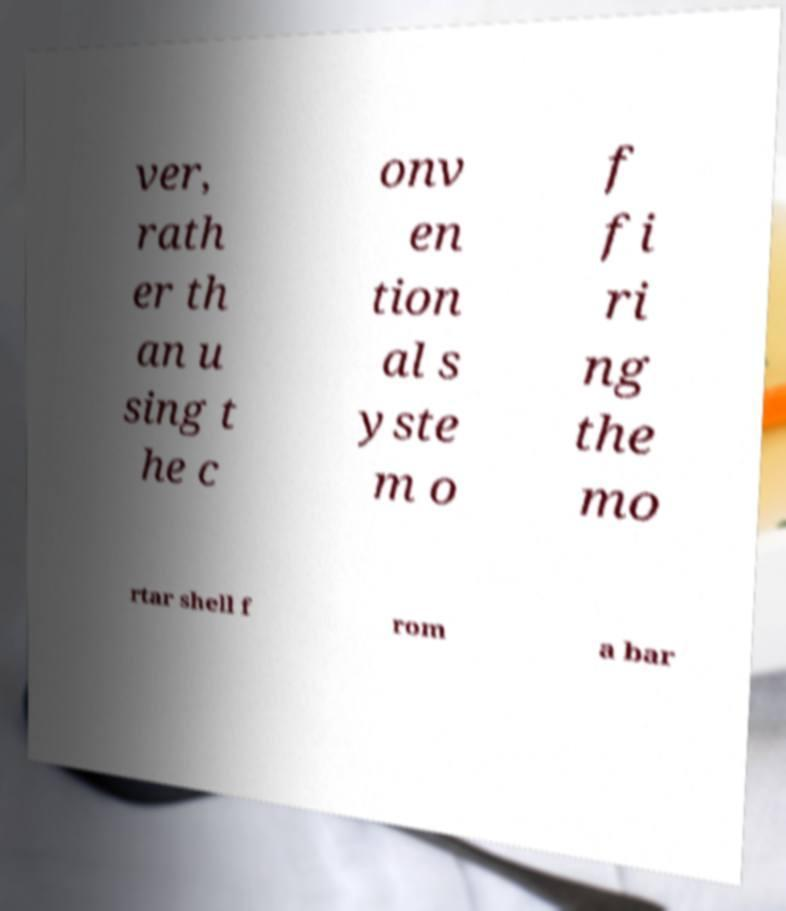Please read and relay the text visible in this image. What does it say? ver, rath er th an u sing t he c onv en tion al s yste m o f fi ri ng the mo rtar shell f rom a bar 